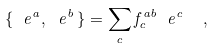<formula> <loc_0><loc_0><loc_500><loc_500>\{ \ e ^ { a } , \ e ^ { b } \, \} = \sum _ { c } f ^ { a b } _ { c } \ e ^ { c } \ \ ,</formula> 